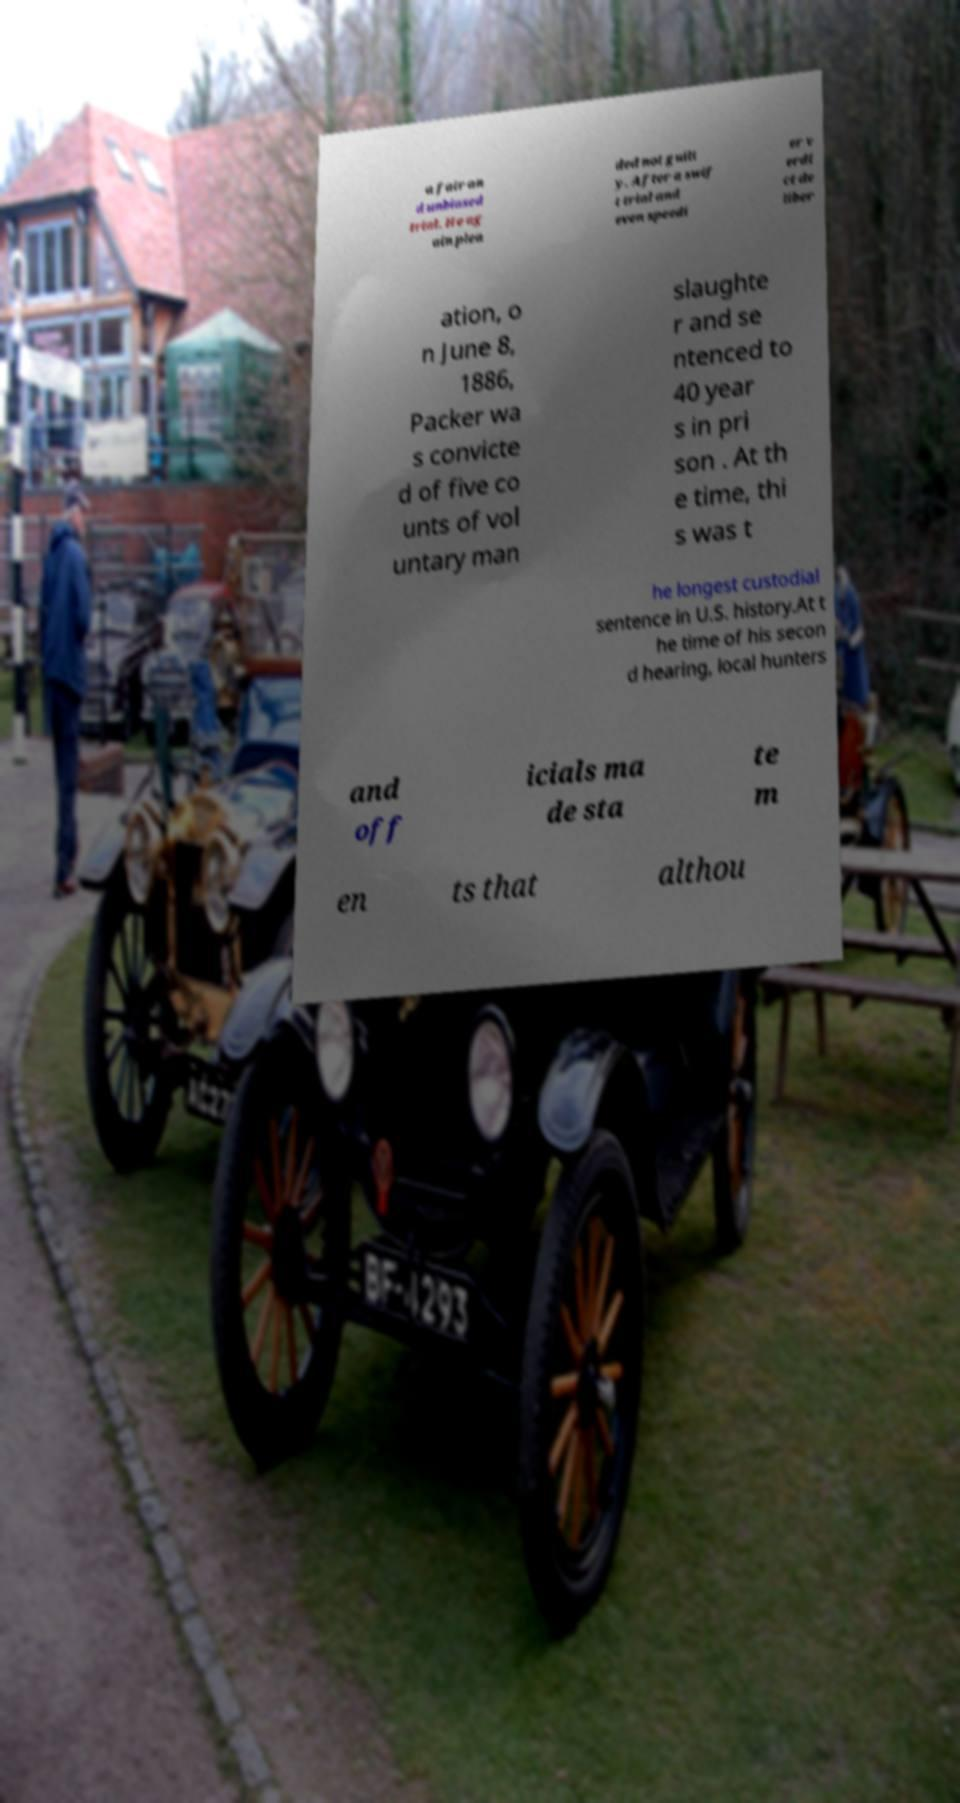Could you assist in decoding the text presented in this image and type it out clearly? a fair an d unbiased trial. He ag ain plea ded not guilt y. After a swif t trial and even speedi er v erdi ct de liber ation, o n June 8, 1886, Packer wa s convicte d of five co unts of vol untary man slaughte r and se ntenced to 40 year s in pri son . At th e time, thi s was t he longest custodial sentence in U.S. history.At t he time of his secon d hearing, local hunters and off icials ma de sta te m en ts that althou 